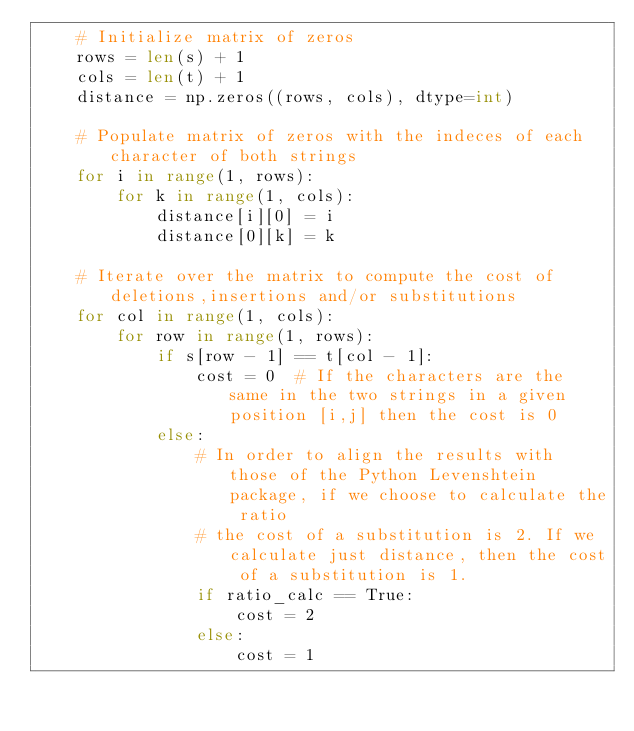<code> <loc_0><loc_0><loc_500><loc_500><_Python_>    # Initialize matrix of zeros
    rows = len(s) + 1
    cols = len(t) + 1
    distance = np.zeros((rows, cols), dtype=int)

    # Populate matrix of zeros with the indeces of each character of both strings
    for i in range(1, rows):
        for k in range(1, cols):
            distance[i][0] = i
            distance[0][k] = k

    # Iterate over the matrix to compute the cost of deletions,insertions and/or substitutions
    for col in range(1, cols):
        for row in range(1, rows):
            if s[row - 1] == t[col - 1]:
                cost = 0  # If the characters are the same in the two strings in a given position [i,j] then the cost is 0
            else:
                # In order to align the results with those of the Python Levenshtein package, if we choose to calculate the ratio
                # the cost of a substitution is 2. If we calculate just distance, then the cost of a substitution is 1.
                if ratio_calc == True:
                    cost = 2
                else:
                    cost = 1</code> 